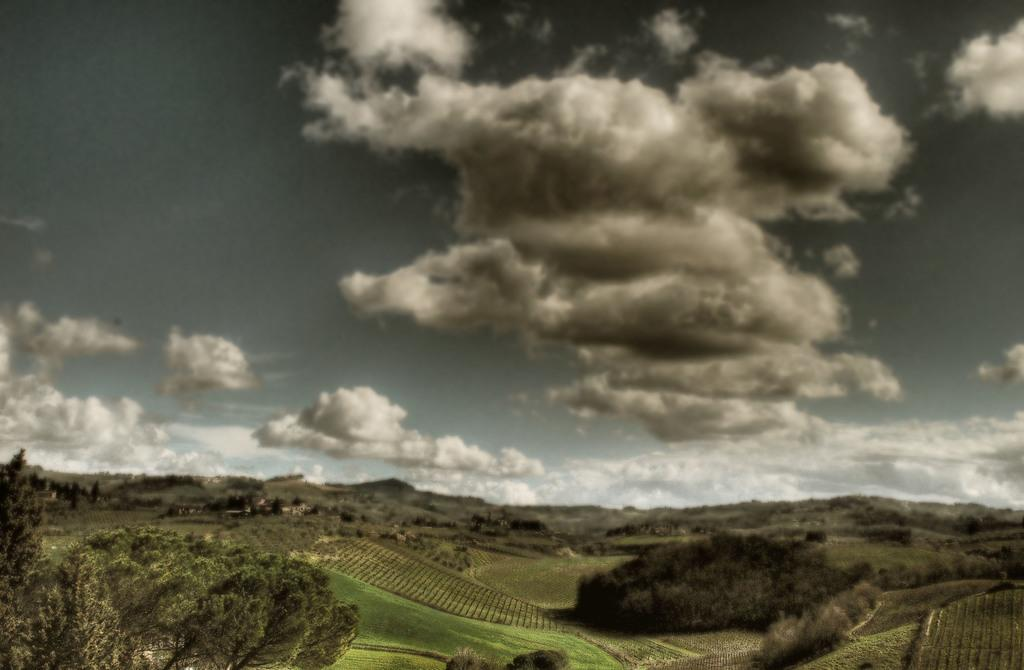What type of vegetation is at the bottom of the picture? There is grass and trees at the bottom of the picture. What else can be seen at the bottom of the picture? There are also trees at the bottom of the picture. What is visible in the background of the picture? There are trees in the background of the picture. What can be seen at the top of the picture? The sky is visible at the top of the picture. What is present in the sky? Clouds are present in the sky. How does the cushion affect the trees in the image? There is no cushion present in the image, so it cannot affect the trees. What type of ship can be seen sailing in the background of the image? There is no ship present in the image; it features grass, trees, and clouds. 